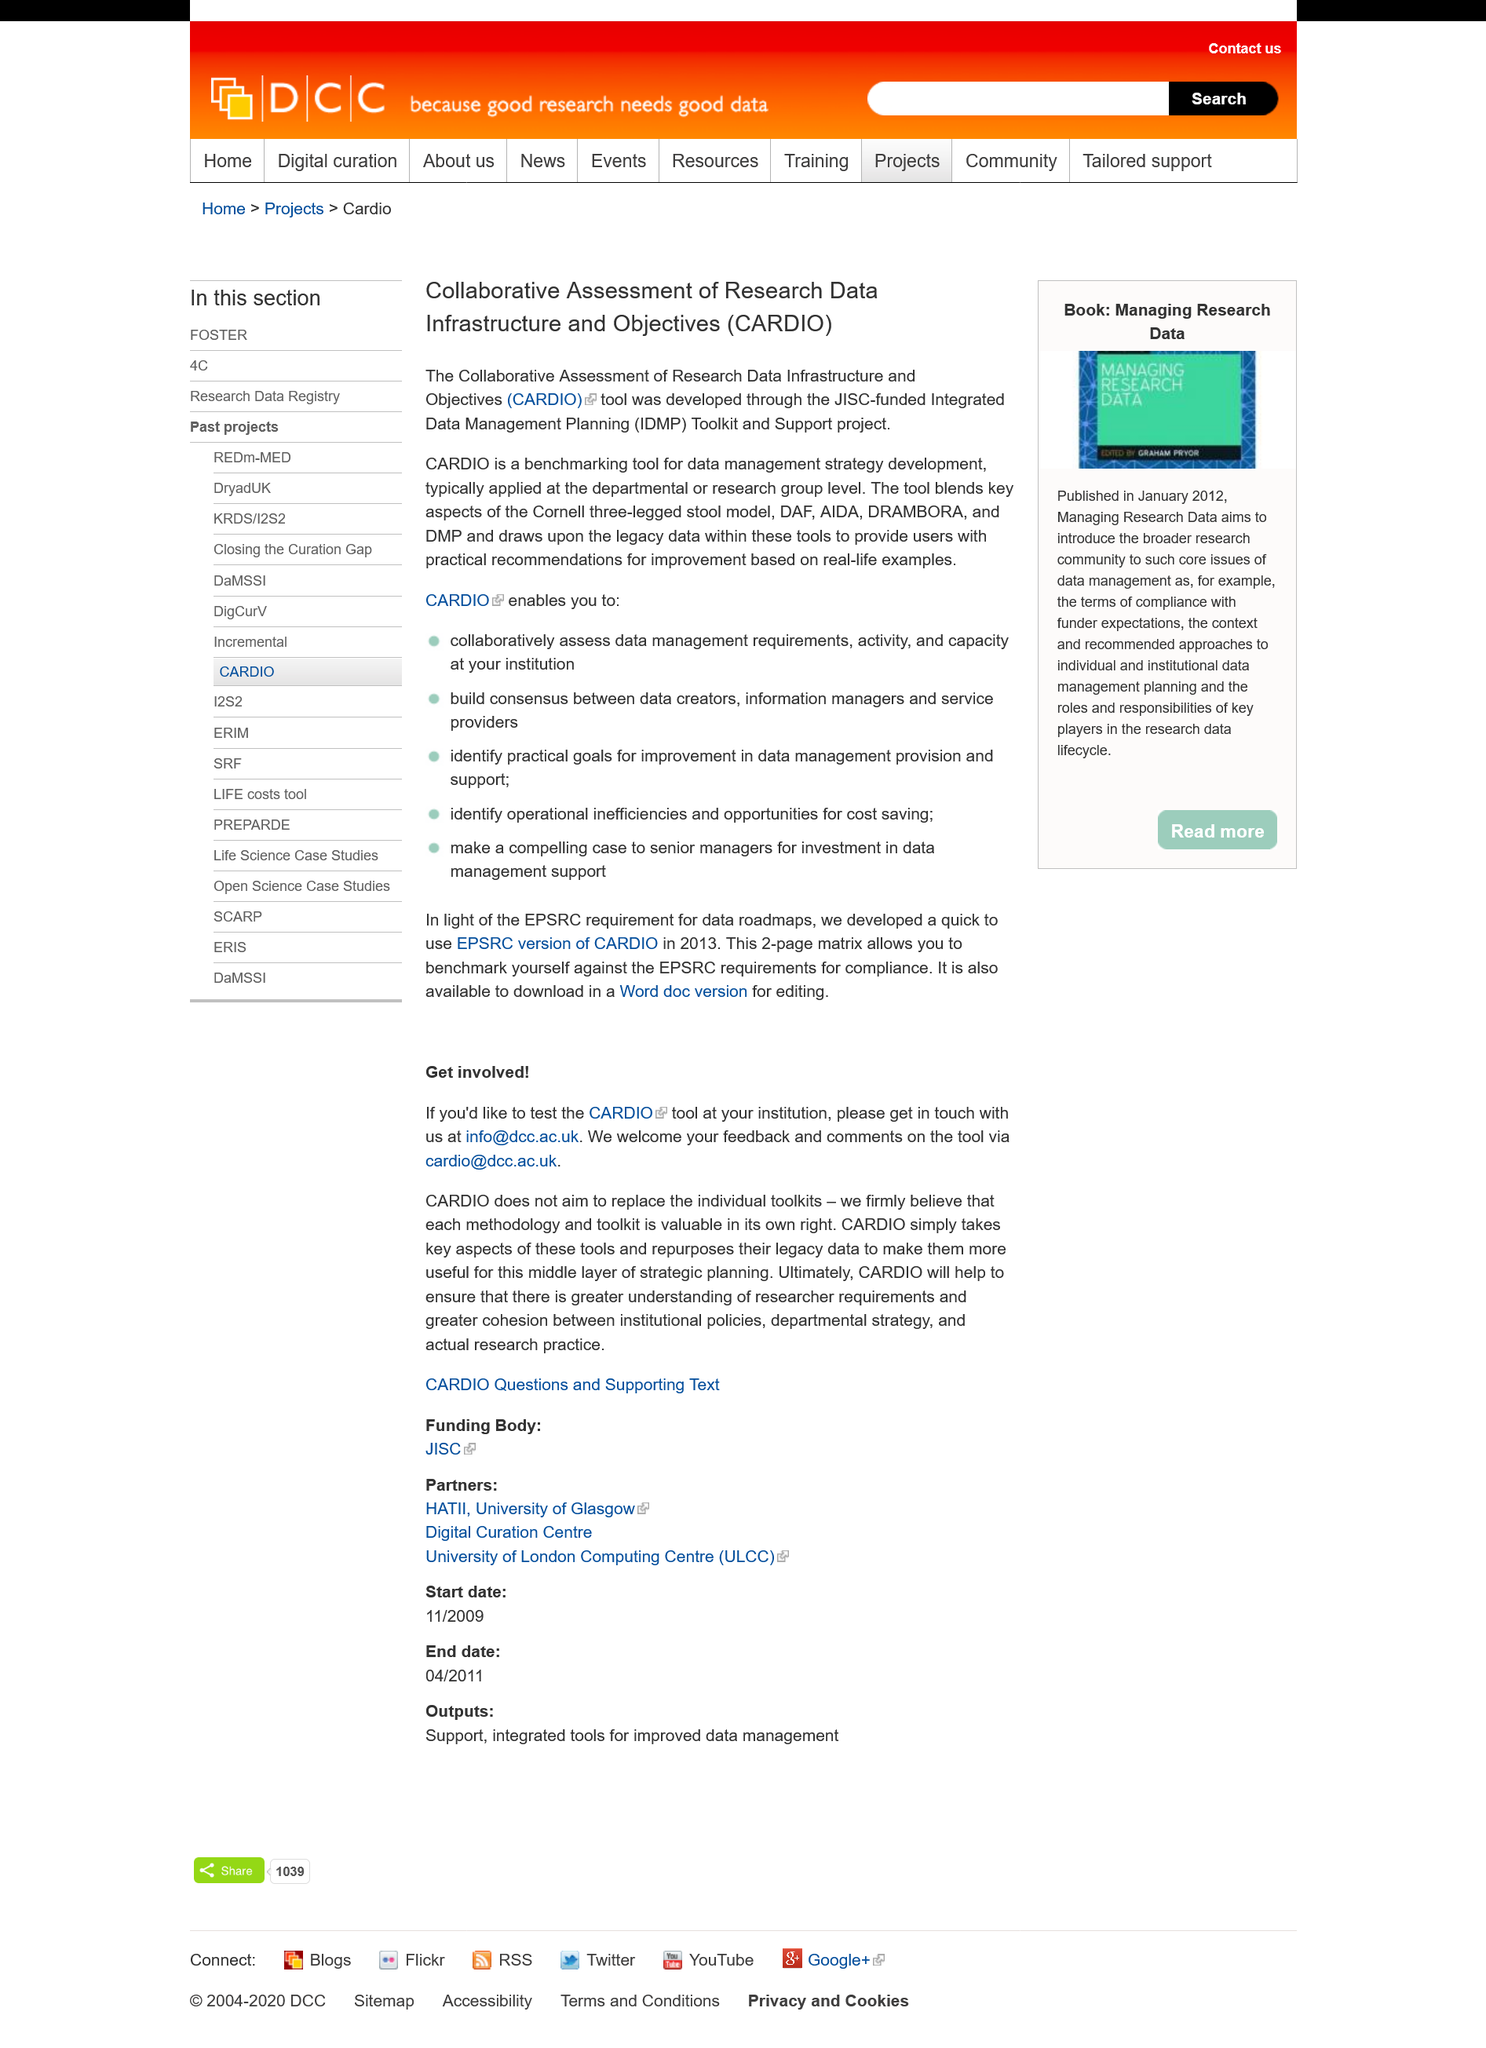Highlight a few significant elements in this photo. The acronym CARDIO stands for Collaborative Assessment of Research Data Infrastructure and Objectives. Integrated Data Management Planning (IDMP) is a process that involves the systematic and coordinated planning, acquisition, management, and dissemination of data to support the decision-making needs of an organization or individual. The data management strategy development benchmarking tool was created through the JISC-funded Integrated Data Management Planning Toolkit and Support project. 